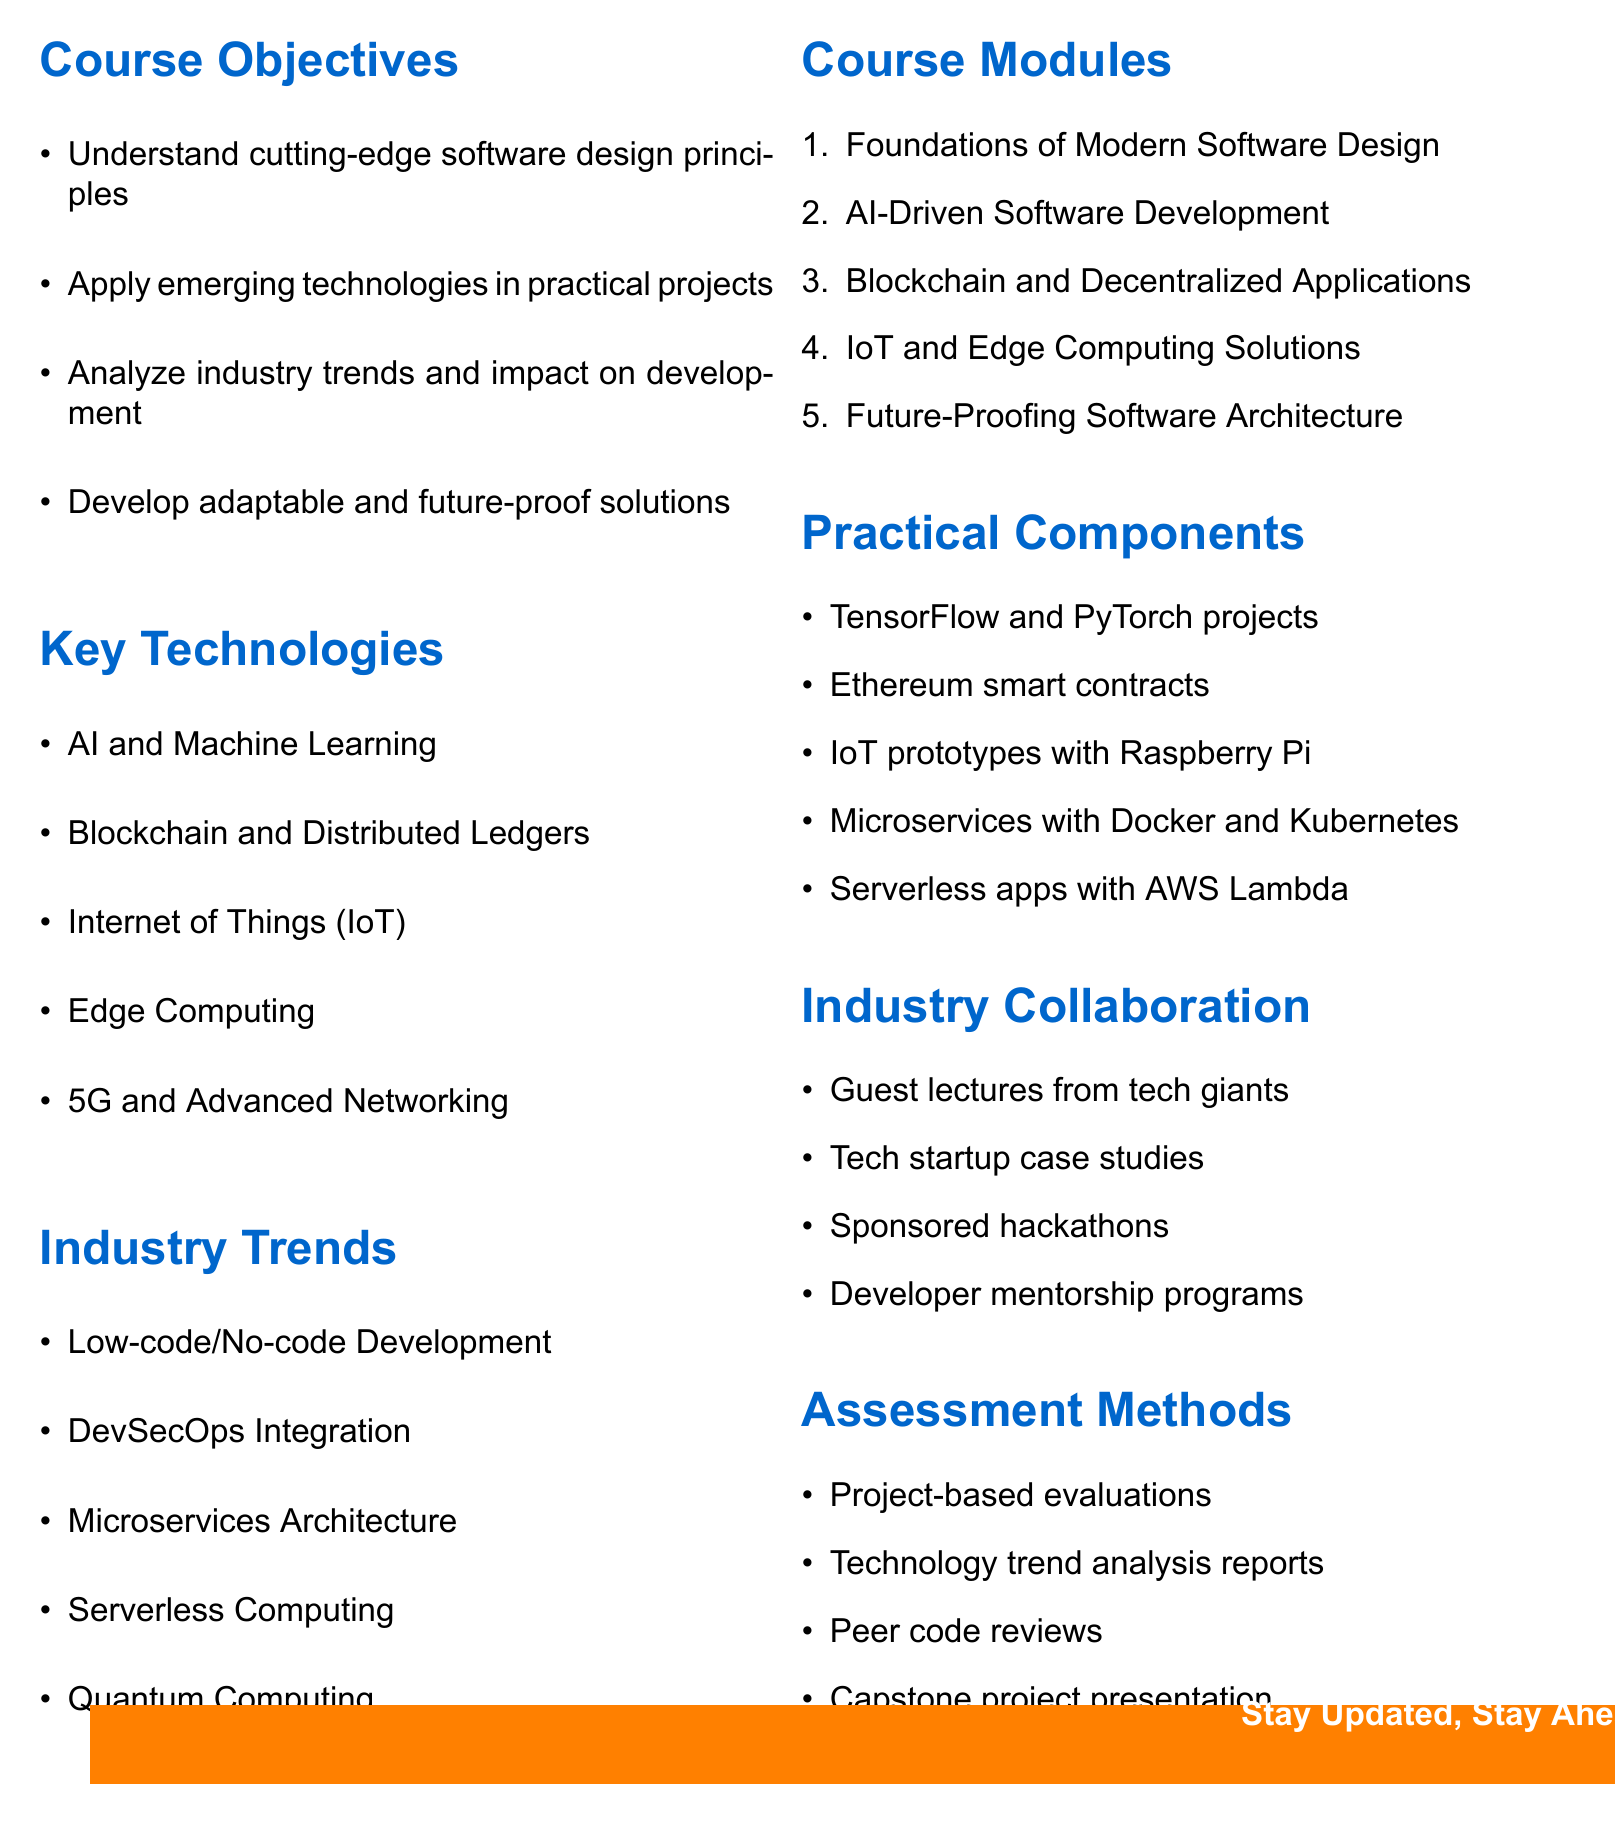What are the course objectives? The course objectives are listed as key points in the document, summarizing the fundamental goals of the course syllabus.
Answer: Understand cutting-edge software design principles, Apply emerging technologies in practical projects, Analyze industry trends and their impact on software development, Develop adaptable and future-proof software solutions What is the first key technology listed? The document specifies key technologies in a list, and the first one is the initial focus of the syllabus.
Answer: Artificial Intelligence and Machine Learning How many course modules are there? The document enumerates the course modules, indicating the quantity included in the syllabus.
Answer: Five What is one practical component of the course? Practical components are highlighted in the document, showing the hands-on aspects students will engage in.
Answer: Hands-on projects using TensorFlow and PyTorch Which industry collaboration event is mentioned? The document outlines various industry collaborations, specifying types of engagements with industry professionals.
Answer: Guest lectures from Google, Microsoft, and Amazon What assessment method involves peers? The assessment methods list includes methods by which students can evaluate each other's work, indicating peer engagement.
Answer: Peer code reviews What emerging industry trend involves coding difficulty levels? One of the industry trends specifically addresses the complexity of coding in software development and design.
Answer: Low-code/No-code Development What is the second course module? The document lists course modules in an ordered format, allowing easy identification of each module's sequence.
Answer: AI-Driven Software Development 